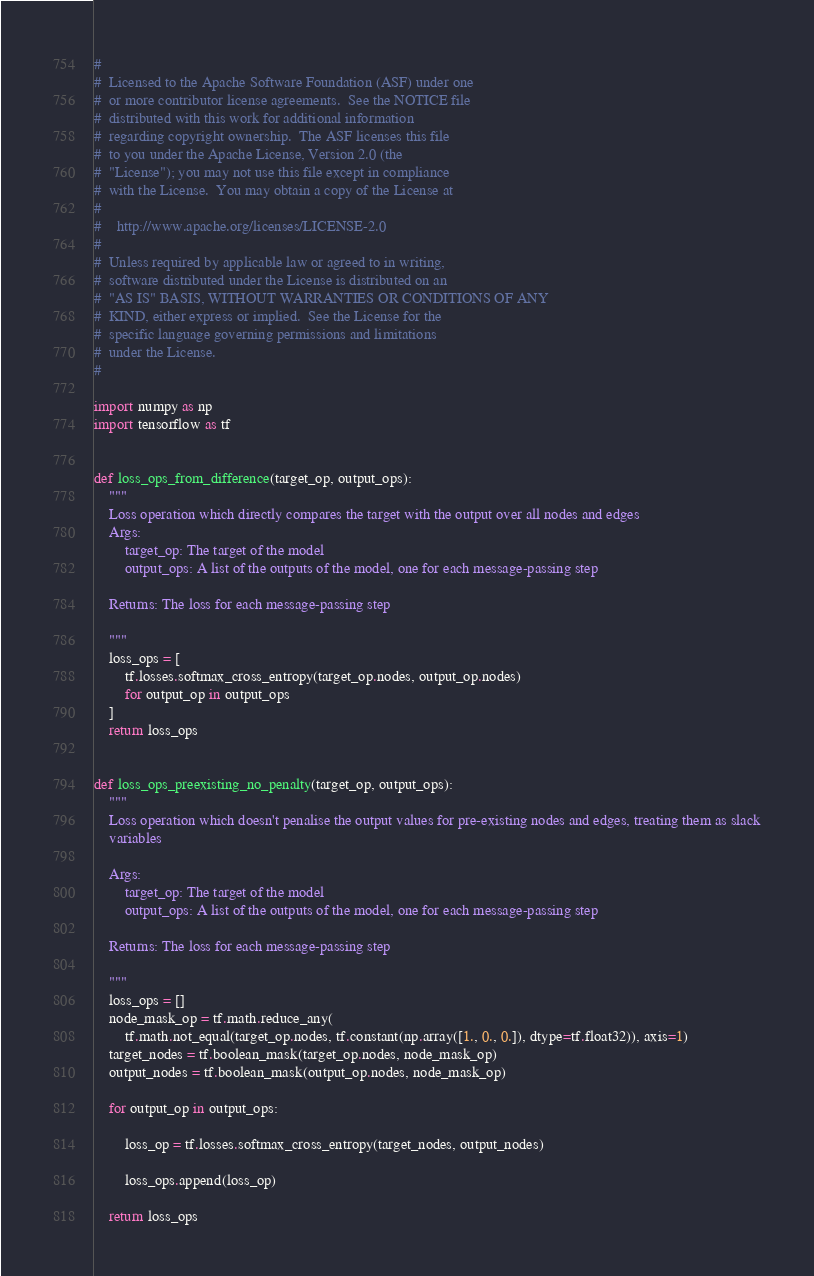Convert code to text. <code><loc_0><loc_0><loc_500><loc_500><_Python_>#
#  Licensed to the Apache Software Foundation (ASF) under one
#  or more contributor license agreements.  See the NOTICE file
#  distributed with this work for additional information
#  regarding copyright ownership.  The ASF licenses this file
#  to you under the Apache License, Version 2.0 (the
#  "License"); you may not use this file except in compliance
#  with the License.  You may obtain a copy of the License at
#
#    http://www.apache.org/licenses/LICENSE-2.0
#
#  Unless required by applicable law or agreed to in writing,
#  software distributed under the License is distributed on an
#  "AS IS" BASIS, WITHOUT WARRANTIES OR CONDITIONS OF ANY
#  KIND, either express or implied.  See the License for the
#  specific language governing permissions and limitations
#  under the License.
#

import numpy as np
import tensorflow as tf


def loss_ops_from_difference(target_op, output_ops):
    """
    Loss operation which directly compares the target with the output over all nodes and edges
    Args:
        target_op: The target of the model
        output_ops: A list of the outputs of the model, one for each message-passing step

    Returns: The loss for each message-passing step

    """
    loss_ops = [
        tf.losses.softmax_cross_entropy(target_op.nodes, output_op.nodes)
        for output_op in output_ops
    ]
    return loss_ops


def loss_ops_preexisting_no_penalty(target_op, output_ops):
    """
    Loss operation which doesn't penalise the output values for pre-existing nodes and edges, treating them as slack
    variables

    Args:
        target_op: The target of the model
        output_ops: A list of the outputs of the model, one for each message-passing step

    Returns: The loss for each message-passing step

    """
    loss_ops = []
    node_mask_op = tf.math.reduce_any(
        tf.math.not_equal(target_op.nodes, tf.constant(np.array([1., 0., 0.]), dtype=tf.float32)), axis=1)
    target_nodes = tf.boolean_mask(target_op.nodes, node_mask_op)
    output_nodes = tf.boolean_mask(output_op.nodes, node_mask_op)

    for output_op in output_ops:

        loss_op = tf.losses.softmax_cross_entropy(target_nodes, output_nodes)

        loss_ops.append(loss_op)

    return loss_ops</code> 